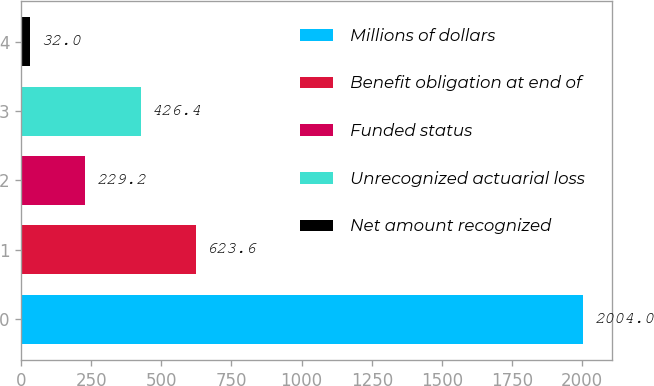Convert chart to OTSL. <chart><loc_0><loc_0><loc_500><loc_500><bar_chart><fcel>Millions of dollars<fcel>Benefit obligation at end of<fcel>Funded status<fcel>Unrecognized actuarial loss<fcel>Net amount recognized<nl><fcel>2004<fcel>623.6<fcel>229.2<fcel>426.4<fcel>32<nl></chart> 